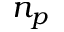<formula> <loc_0><loc_0><loc_500><loc_500>n _ { p }</formula> 